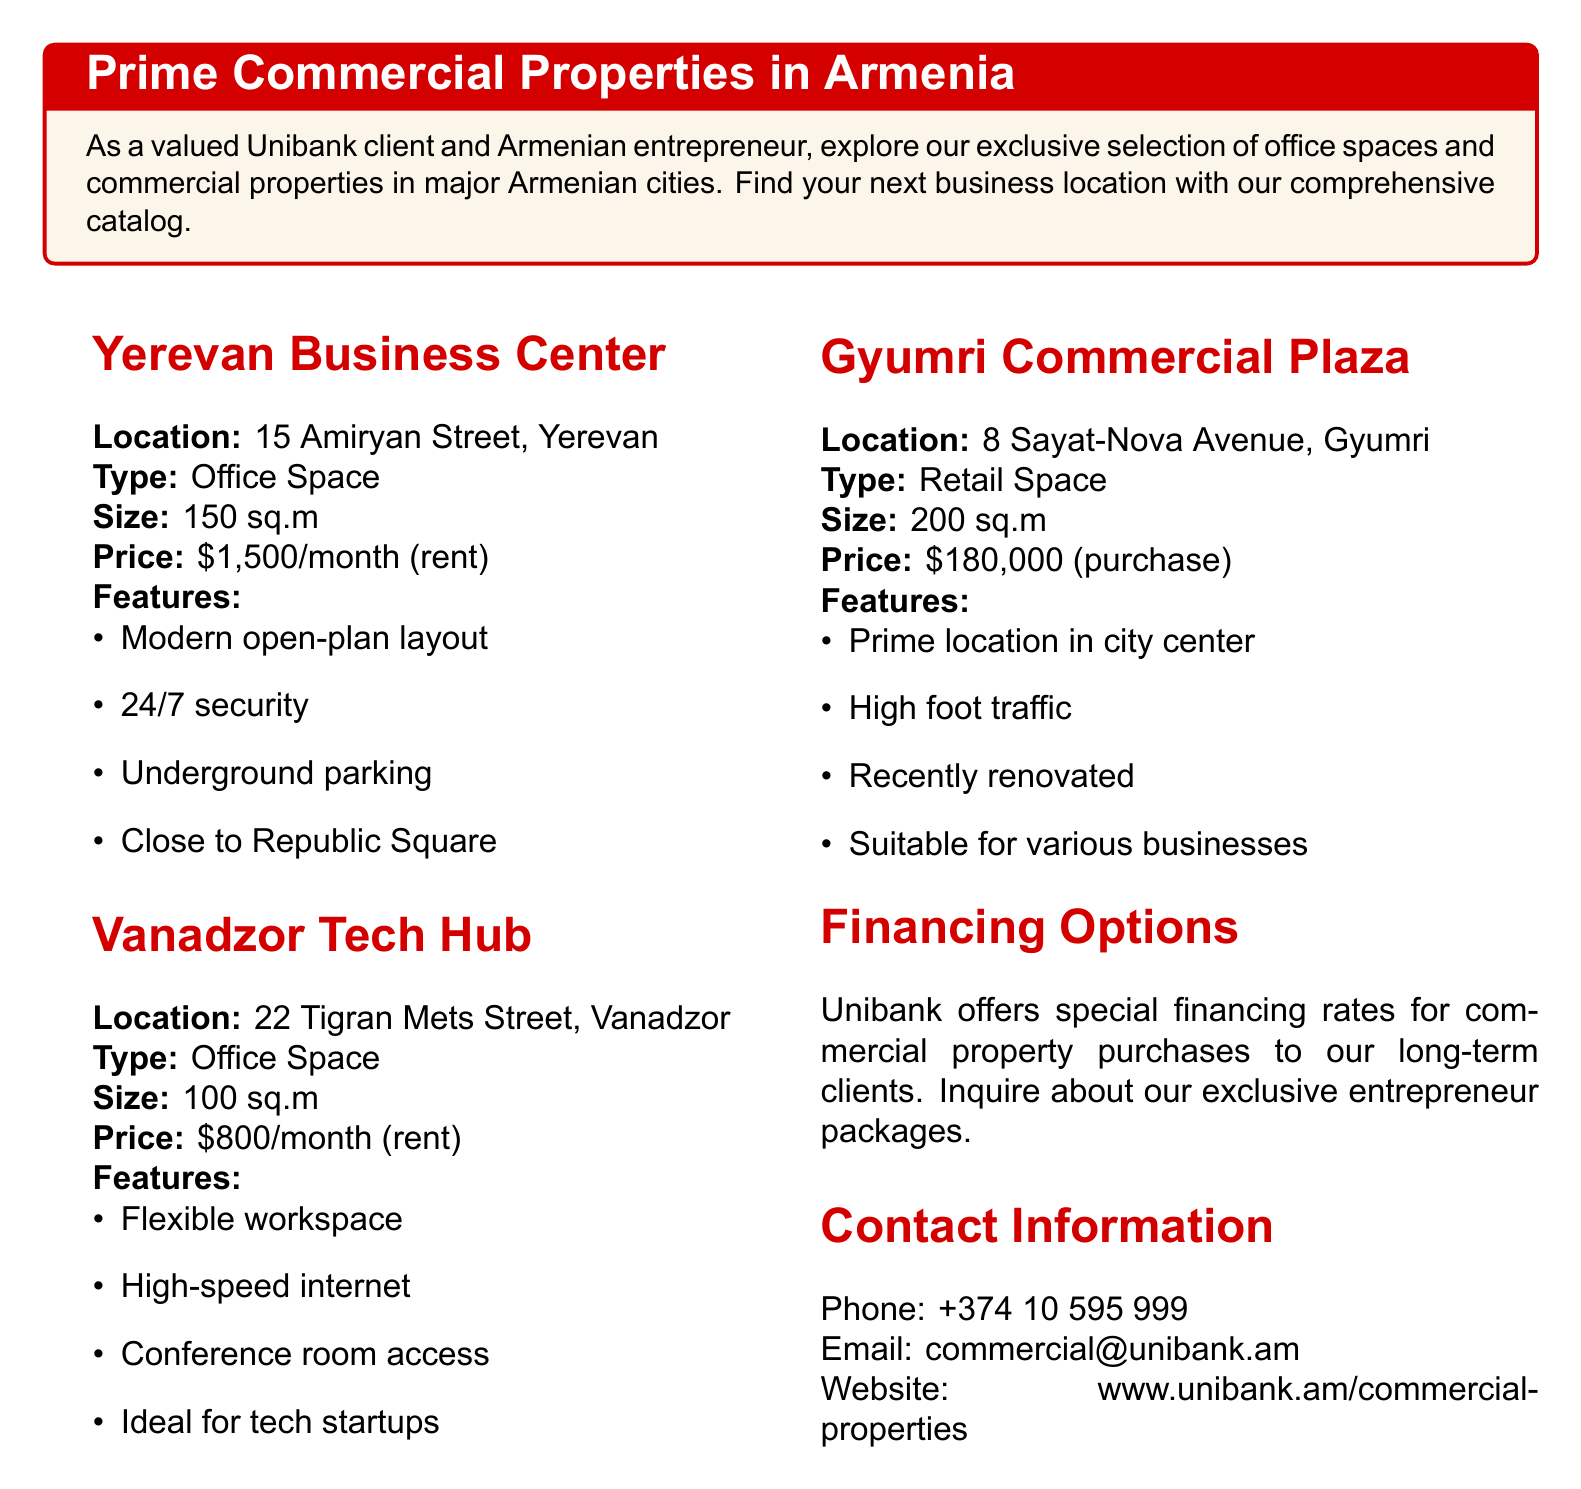What is the size of the Yerevan Business Center? The size of the Yerevan Business Center is specified in the document as 150 sq.m.
Answer: 150 sq.m What is the price of the Gyumri Commercial Plaza? The document states that the price for purchasing the Gyumri Commercial Plaza is $180,000.
Answer: $180,000 Where is the Vanadzor Tech Hub located? The specific address of the Vanadzor Tech Hub is provided in the document as 22 Tigran Mets Street, Vanadzor.
Answer: 22 Tigran Mets Street, Vanadzor What features are included with the office space at Yerevan Business Center? The document lists features such as modern open-plan layout, 24/7 security, and underground parking for the Yerevan Business Center.
Answer: Modern open-plan layout, 24/7 security, underground parking What type of property is available at Vanadzor? The document categorizes the Vanadzor property as office space.
Answer: Office Space What is the contact email for commercial properties at Unibank? The document provides the email address for inquiries regarding commercial properties as commercial@unibank.am.
Answer: commercial@unibank.am What kind of financing options does Unibank offer? The document mentions that Unibank offers special financing rates for commercial property purchases to long-term clients.
Answer: Special financing rates What is the price per month for renting office space in Yerevan? The document states that the rental price for office space in Yerevan is $1,500 per month.
Answer: $1,500/month What are the features of the Gyumri Commercial Plaza? The document lists features like prime location in city center, high foot traffic, and recently renovated for Gyumri Commercial Plaza.
Answer: Prime location in city center, high foot traffic, recently renovated 